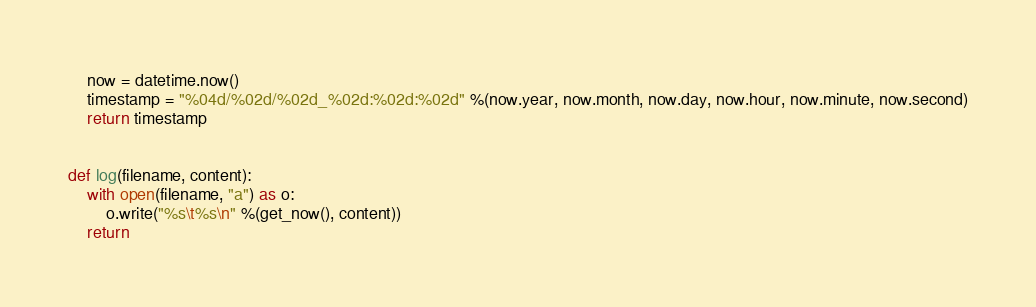<code> <loc_0><loc_0><loc_500><loc_500><_Python_>    now = datetime.now()
    timestamp = "%04d/%02d/%02d_%02d:%02d:%02d" %(now.year, now.month, now.day, now.hour, now.minute, now.second)
    return timestamp


def log(filename, content):
    with open(filename, "a") as o:
        o.write("%s\t%s\n" %(get_now(), content))
    return
</code> 